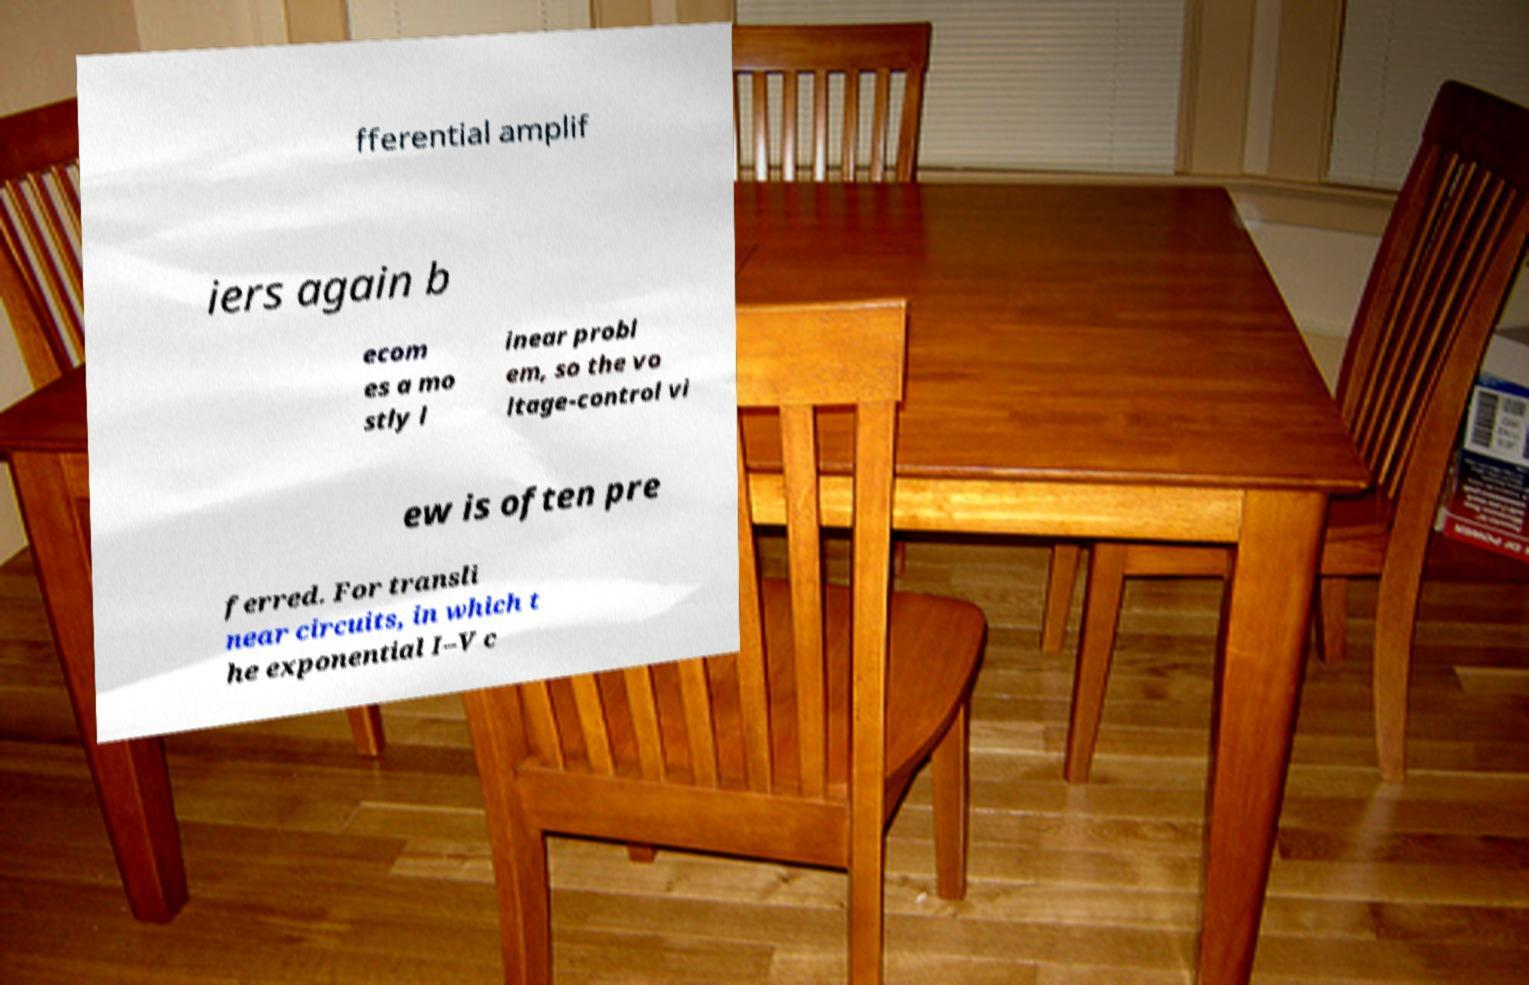I need the written content from this picture converted into text. Can you do that? fferential amplif iers again b ecom es a mo stly l inear probl em, so the vo ltage-control vi ew is often pre ferred. For transli near circuits, in which t he exponential I–V c 